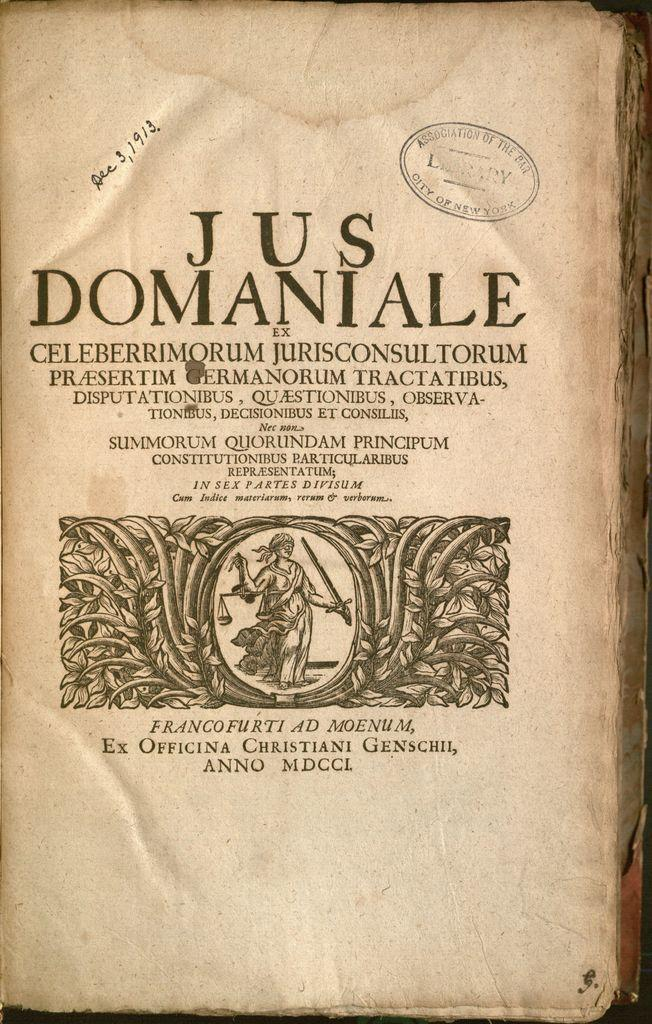Provide a one-sentence caption for the provided image. An antique book stamped by the Association of the Bar in New York City has a handwritten date of Dec 3, 1913 in the upper left section. 